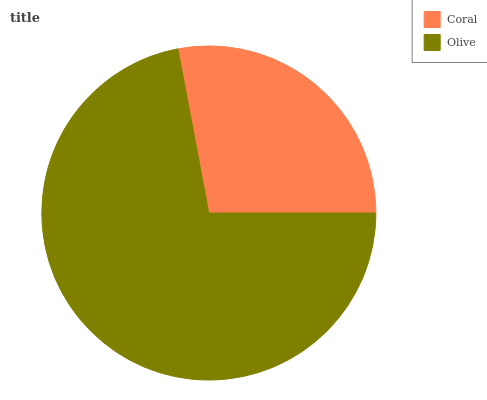Is Coral the minimum?
Answer yes or no. Yes. Is Olive the maximum?
Answer yes or no. Yes. Is Olive the minimum?
Answer yes or no. No. Is Olive greater than Coral?
Answer yes or no. Yes. Is Coral less than Olive?
Answer yes or no. Yes. Is Coral greater than Olive?
Answer yes or no. No. Is Olive less than Coral?
Answer yes or no. No. Is Olive the high median?
Answer yes or no. Yes. Is Coral the low median?
Answer yes or no. Yes. Is Coral the high median?
Answer yes or no. No. Is Olive the low median?
Answer yes or no. No. 